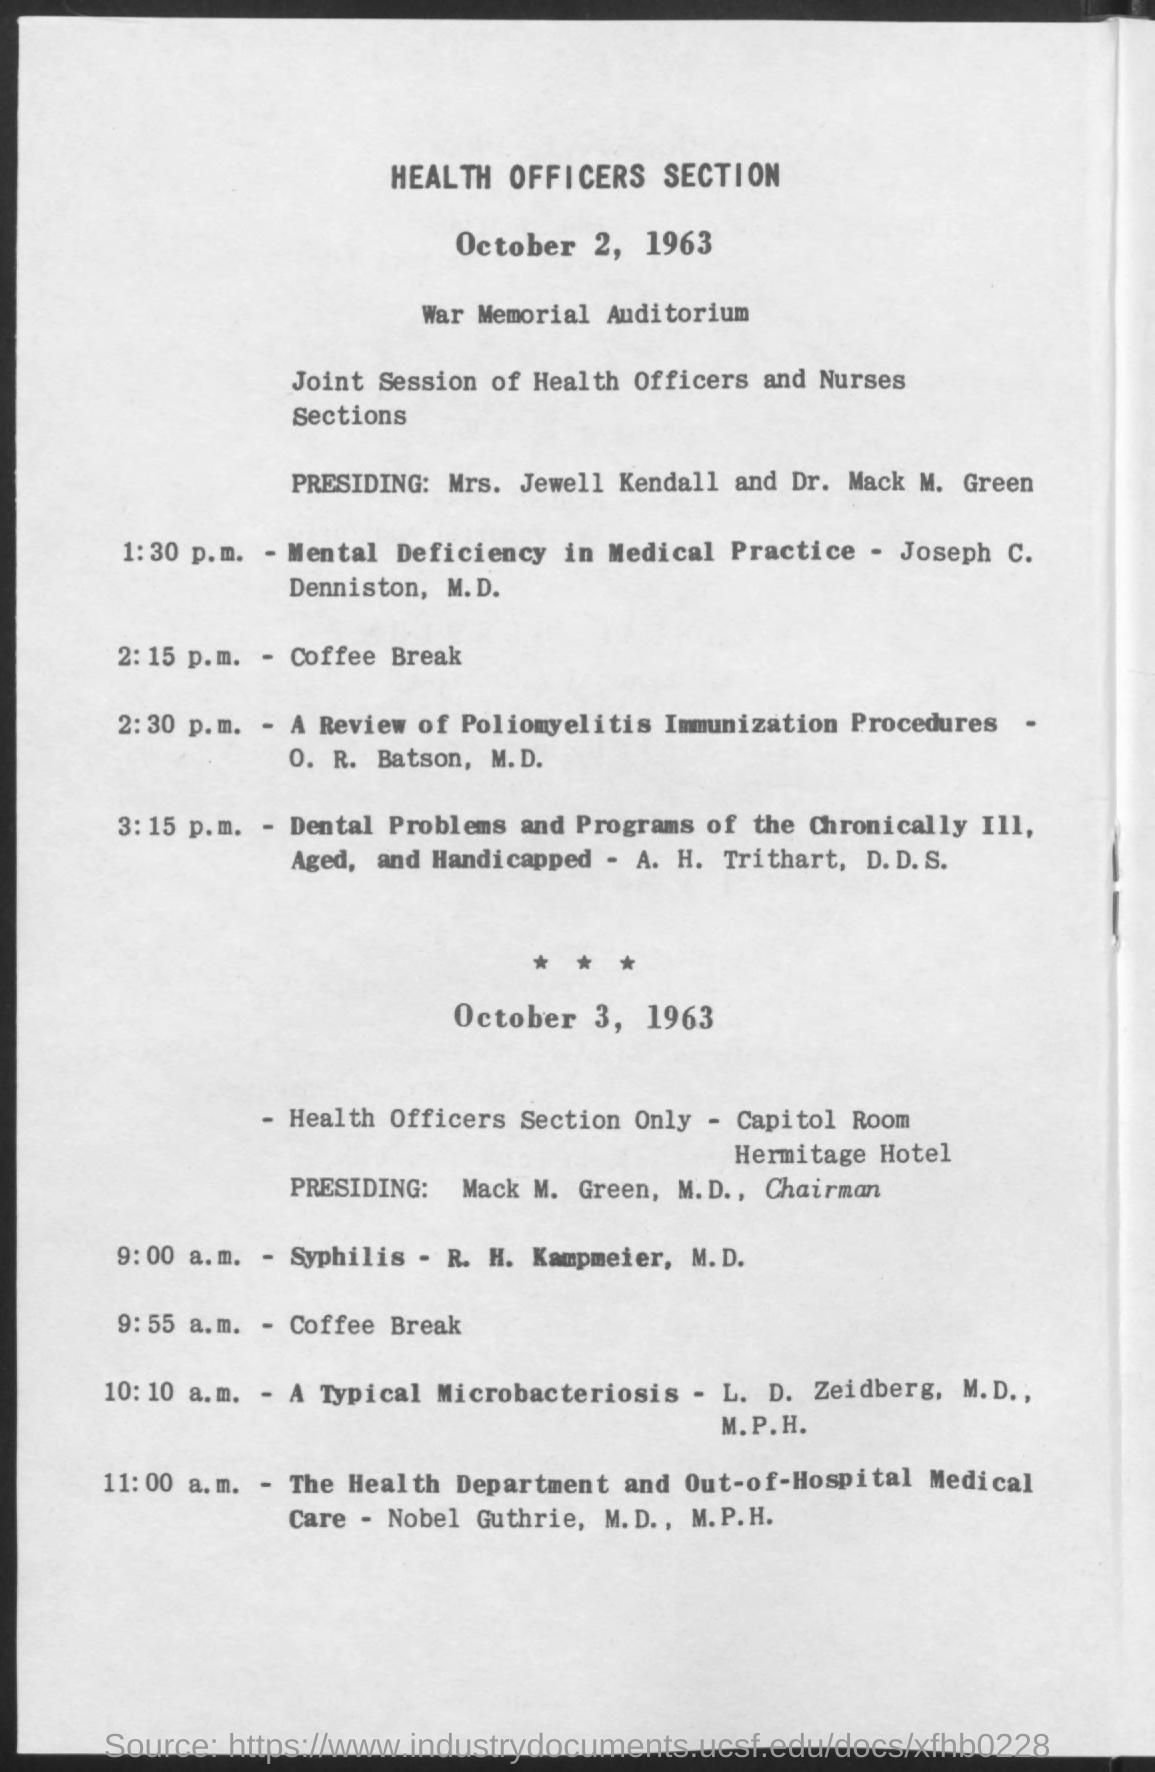Point out several critical features in this image. The event will take place at the War Memorial Auditorium. On October 2, 1963, the coffee break occurred at 2:15 p.m. On October 3, 1963, Mack M. Green, M.D., was presiding. 